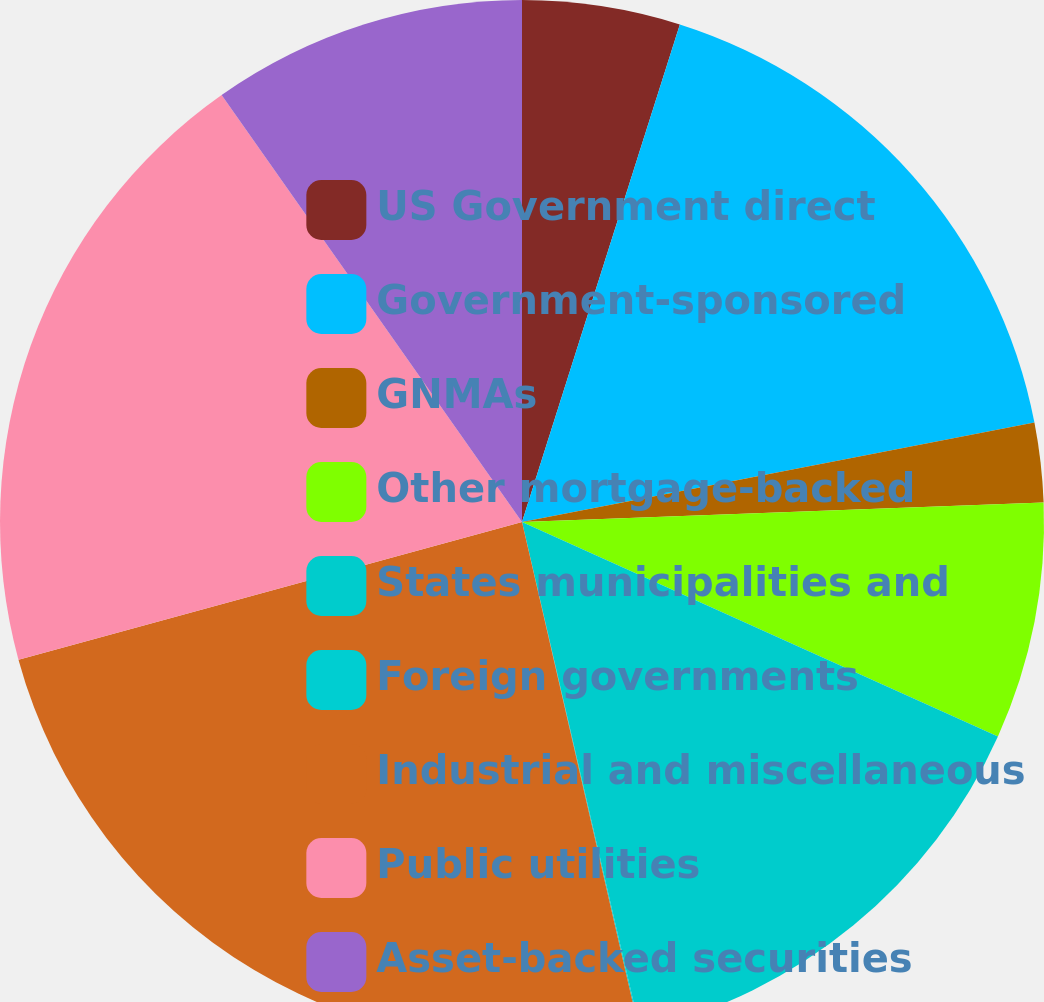Convert chart to OTSL. <chart><loc_0><loc_0><loc_500><loc_500><pie_chart><fcel>US Government direct<fcel>Government-sponsored<fcel>GNMAs<fcel>Other mortgage-backed<fcel>States municipalities and<fcel>Foreign governments<fcel>Industrial and miscellaneous<fcel>Public utilities<fcel>Asset-backed securities<nl><fcel>4.89%<fcel>17.06%<fcel>2.46%<fcel>7.33%<fcel>14.63%<fcel>0.03%<fcel>24.36%<fcel>19.49%<fcel>9.76%<nl></chart> 